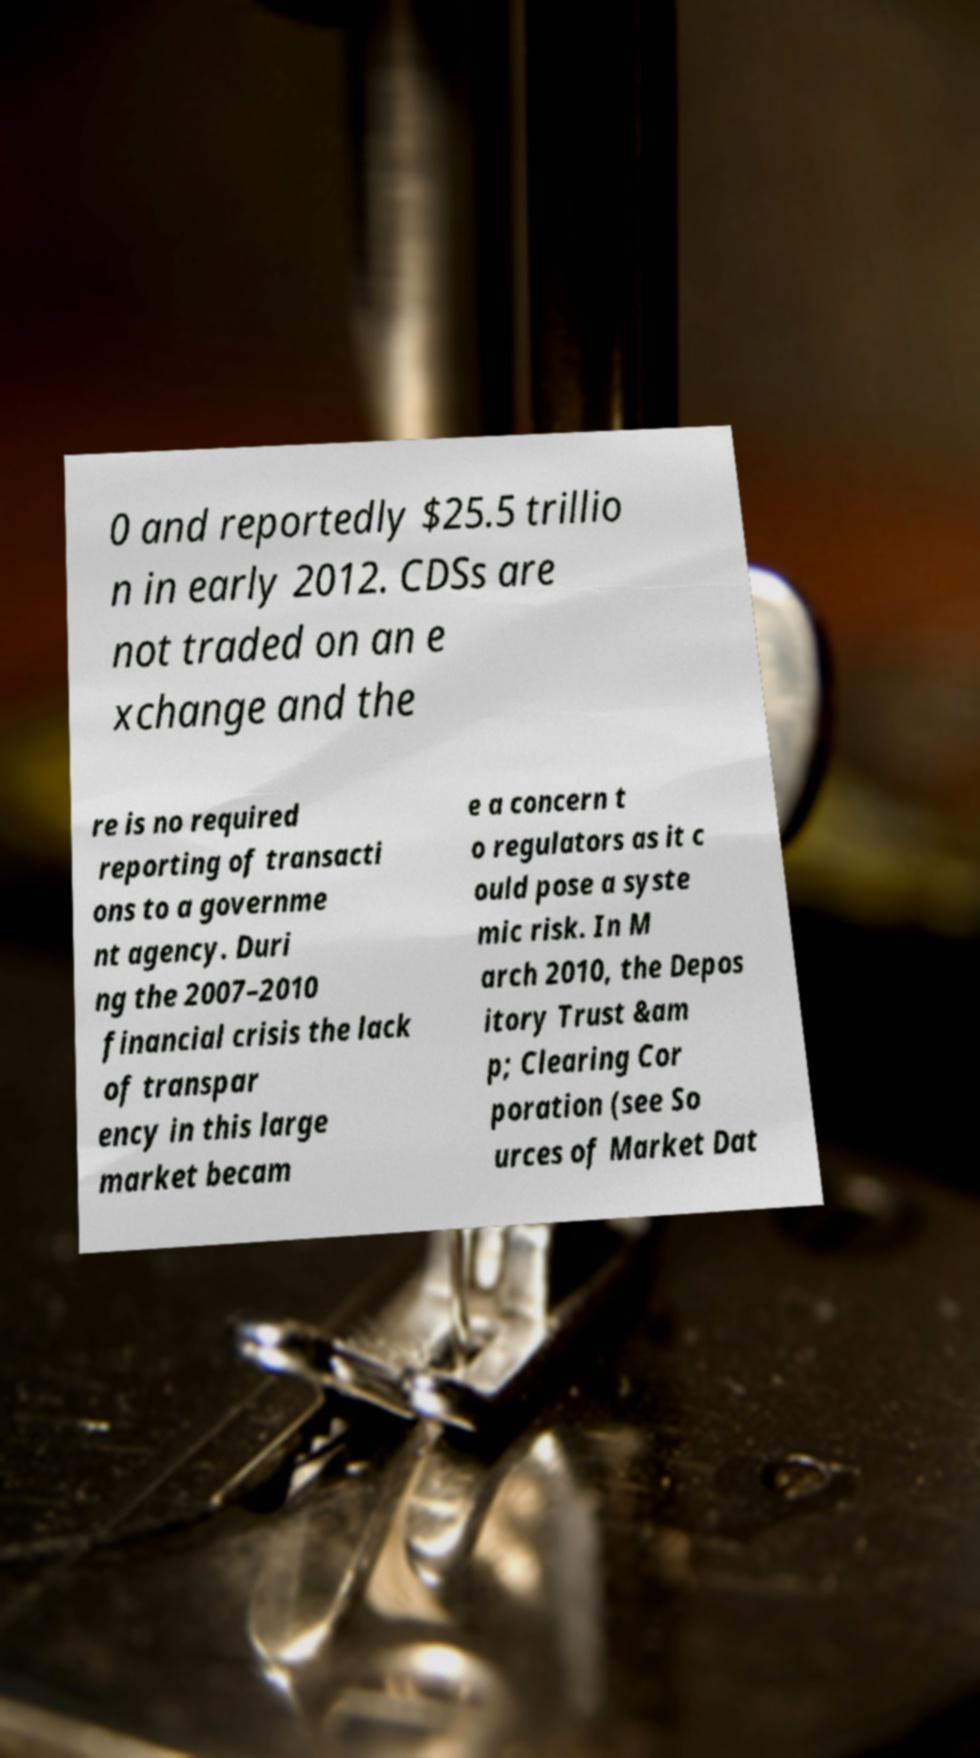Please read and relay the text visible in this image. What does it say? 0 and reportedly $25.5 trillio n in early 2012. CDSs are not traded on an e xchange and the re is no required reporting of transacti ons to a governme nt agency. Duri ng the 2007–2010 financial crisis the lack of transpar ency in this large market becam e a concern t o regulators as it c ould pose a syste mic risk. In M arch 2010, the Depos itory Trust &am p; Clearing Cor poration (see So urces of Market Dat 